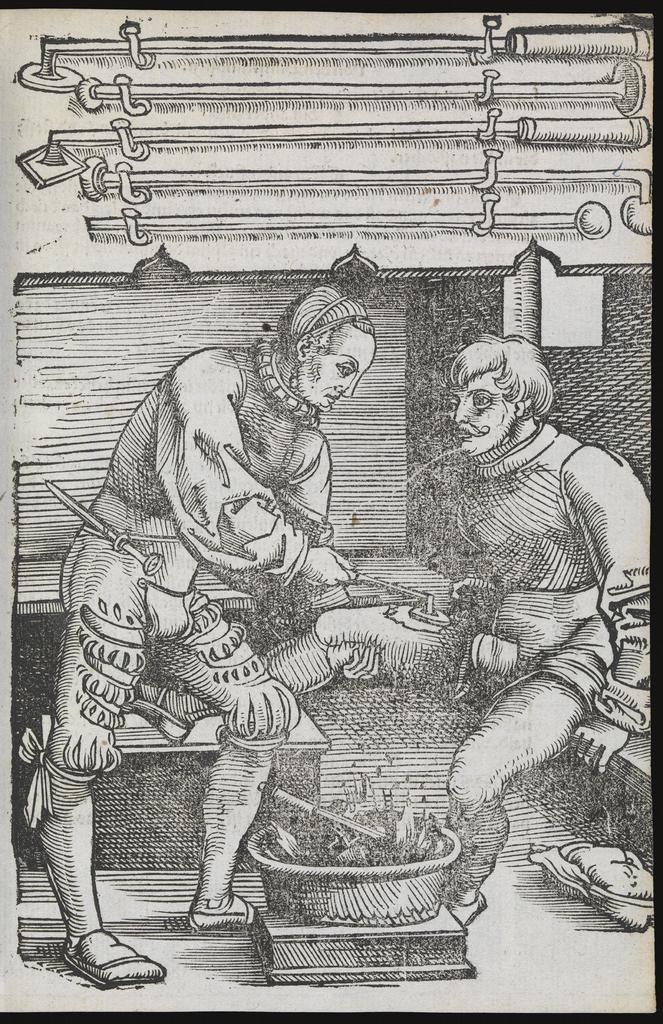Please provide a concise description of this image. In this picture I can see a poster on which I can see few persons and something. 